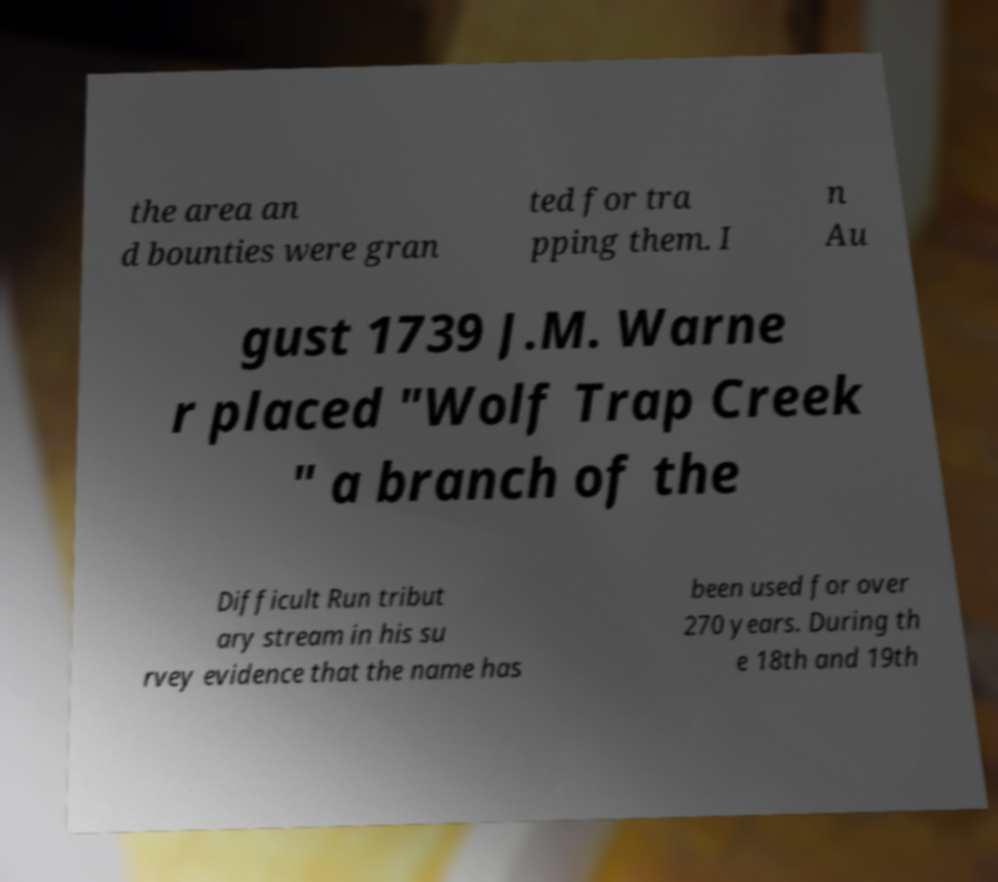I need the written content from this picture converted into text. Can you do that? the area an d bounties were gran ted for tra pping them. I n Au gust 1739 J.M. Warne r placed "Wolf Trap Creek " a branch of the Difficult Run tribut ary stream in his su rvey evidence that the name has been used for over 270 years. During th e 18th and 19th 